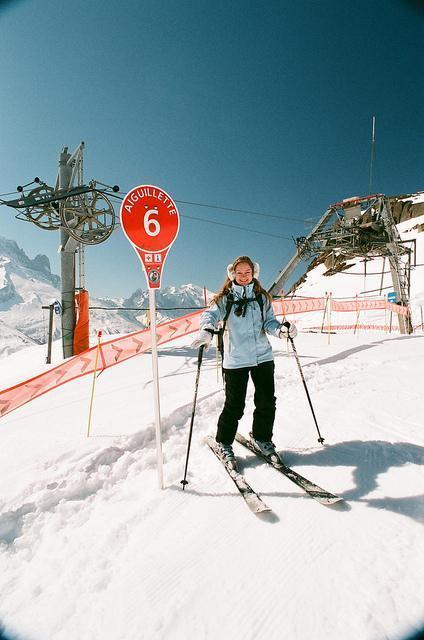How many zebras are facing away from the camera?
Give a very brief answer. 0. 